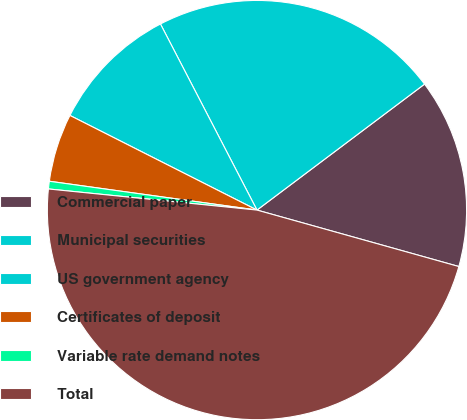Convert chart to OTSL. <chart><loc_0><loc_0><loc_500><loc_500><pie_chart><fcel>Commercial paper<fcel>Municipal securities<fcel>US government agency<fcel>Certificates of deposit<fcel>Variable rate demand notes<fcel>Total<nl><fcel>14.6%<fcel>22.36%<fcel>9.93%<fcel>5.26%<fcel>0.59%<fcel>47.27%<nl></chart> 